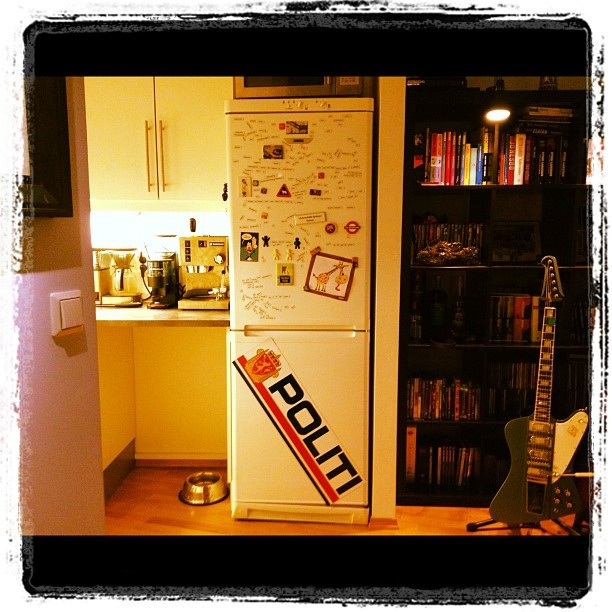Describe the objects in this image and their specific colors. I can see refrigerator in white, orange, khaki, and tan tones, book in white, black, maroon, and brown tones, book in white, black, maroon, and brown tones, book in white, black, maroon, and brown tones, and book in white, black, maroon, and brown tones in this image. 